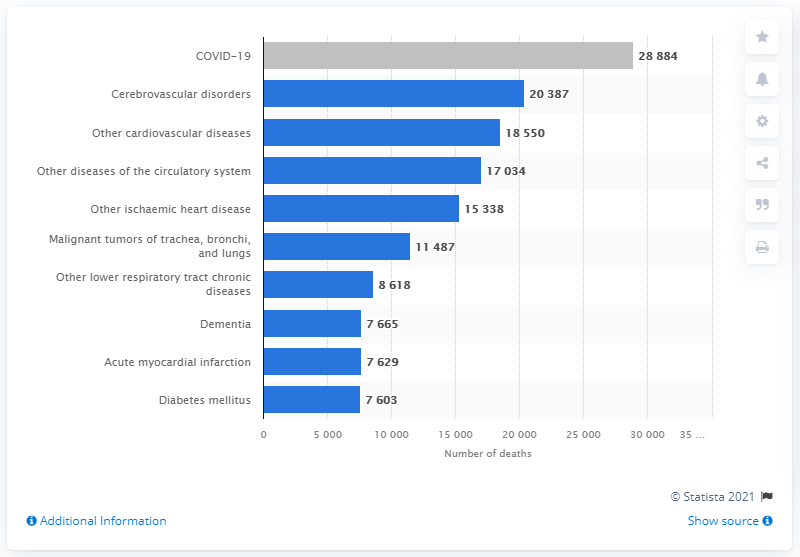Indicate a few pertinent items in this graphic. As of May 3, 2020, the total number of deaths related to the coronavirus was 28,884. According to data from 2038, cerebrovascular disorders were responsible for a significant number of deaths. The difference in death rates between dementia and diabetes mellitus is 62%. Cerebrovascular disorders were the second leading cause of death in Italy in 2020, following closely behind cardiovascular disease. 